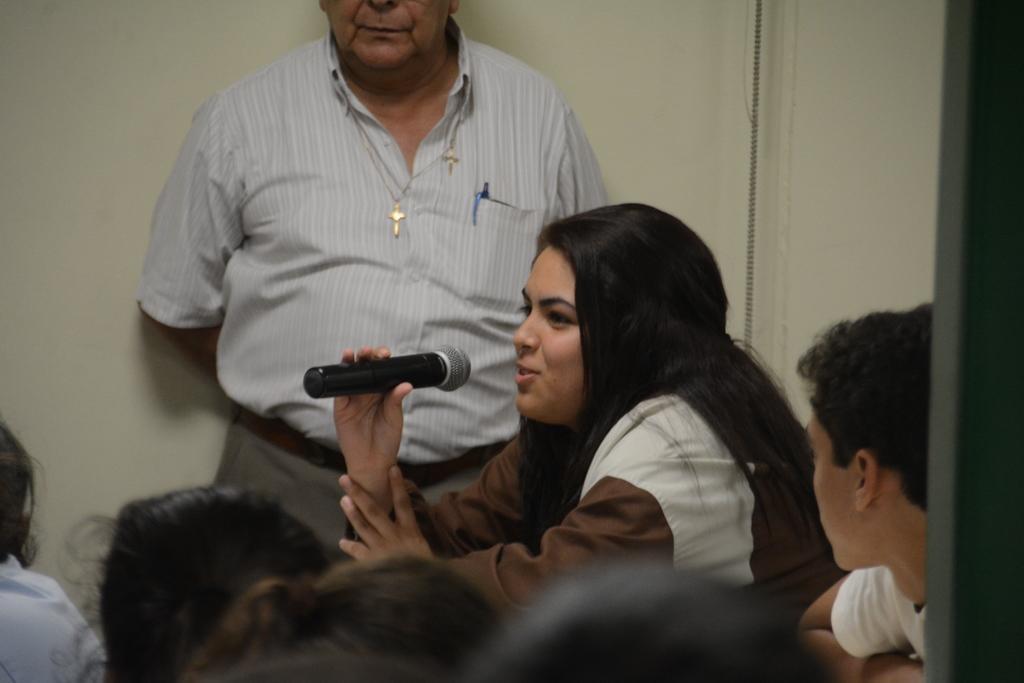Can you describe this image briefly? In this image we can see a woman is holding a mike in her hand and a man is standing at the wall. At the bottom we can see few persons heads and on the right side there is a pole and a person. 